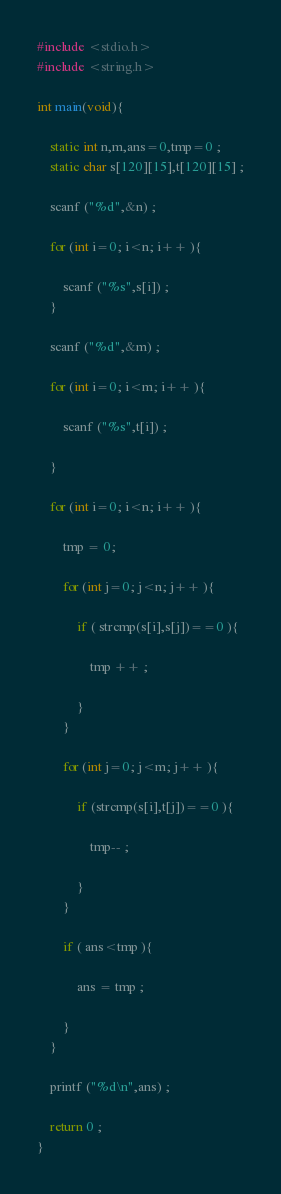Convert code to text. <code><loc_0><loc_0><loc_500><loc_500><_C_>#include <stdio.h>
#include <string.h>

int main(void){

    static int n,m,ans=0,tmp=0 ;
    static char s[120][15],t[120][15] ;
    
    scanf ("%d",&n) ;
    
    for (int i=0; i<n; i++ ){
        
        scanf ("%s",s[i]) ;
    }
    
    scanf ("%d",&m) ;
    
    for (int i=0; i<m; i++ ){
    
        scanf ("%s",t[i]) ;
        
    }
    
    for (int i=0; i<n; i++ ){
        
        tmp = 0;
        
        for (int j=0; j<n; j++ ){
            
            if ( strcmp(s[i],s[j])==0 ){
                
                tmp ++ ;
                
            }
        }    
        
        for (int j=0; j<m; j++ ){
            
            if (strcmp(s[i],t[j])==0 ){
                
                tmp-- ;
                
            }
        }
        
        if ( ans<tmp ){
            
            ans = tmp ;
            
        }
    }

    printf ("%d\n",ans) ;
    
    return 0 ;
}</code> 